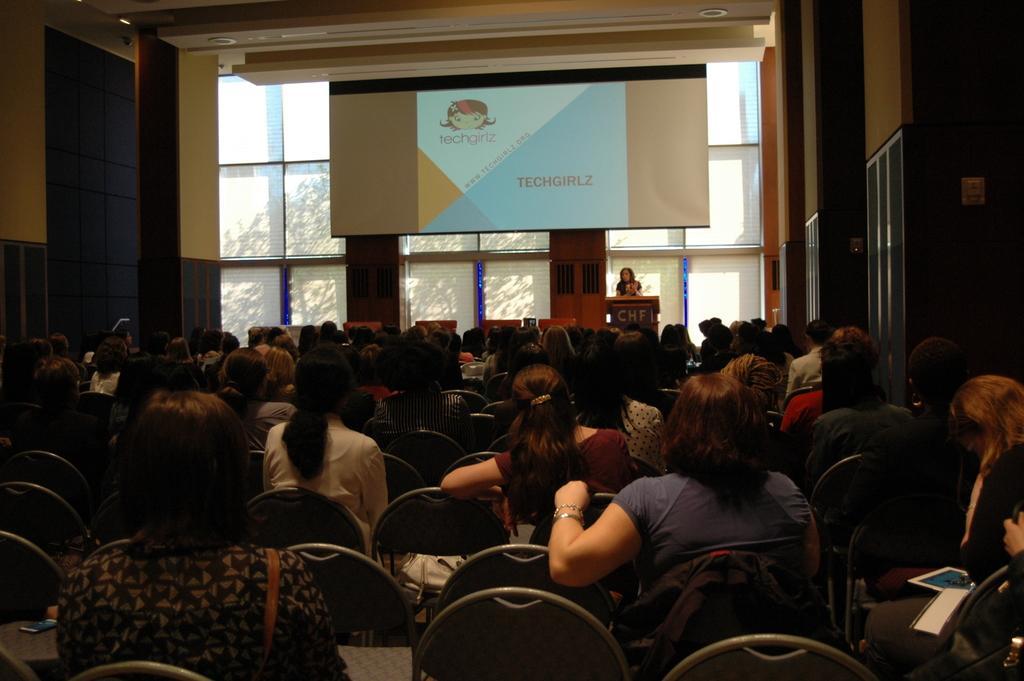How would you summarize this image in a sentence or two? This picture describes about group of people, few are seated on the chairs, and a woman is standing, in front of the podium, in the background we can see a projector screen and few trees. 